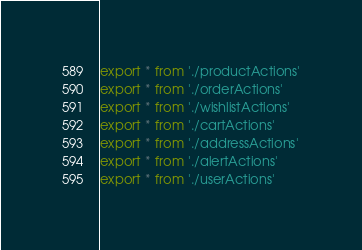<code> <loc_0><loc_0><loc_500><loc_500><_TypeScript_>export * from './productActions'
export * from './orderActions'
export * from './wishlistActions'
export * from './cartActions'
export * from './addressActions'
export * from './alertActions'
export * from './userActions'
</code> 